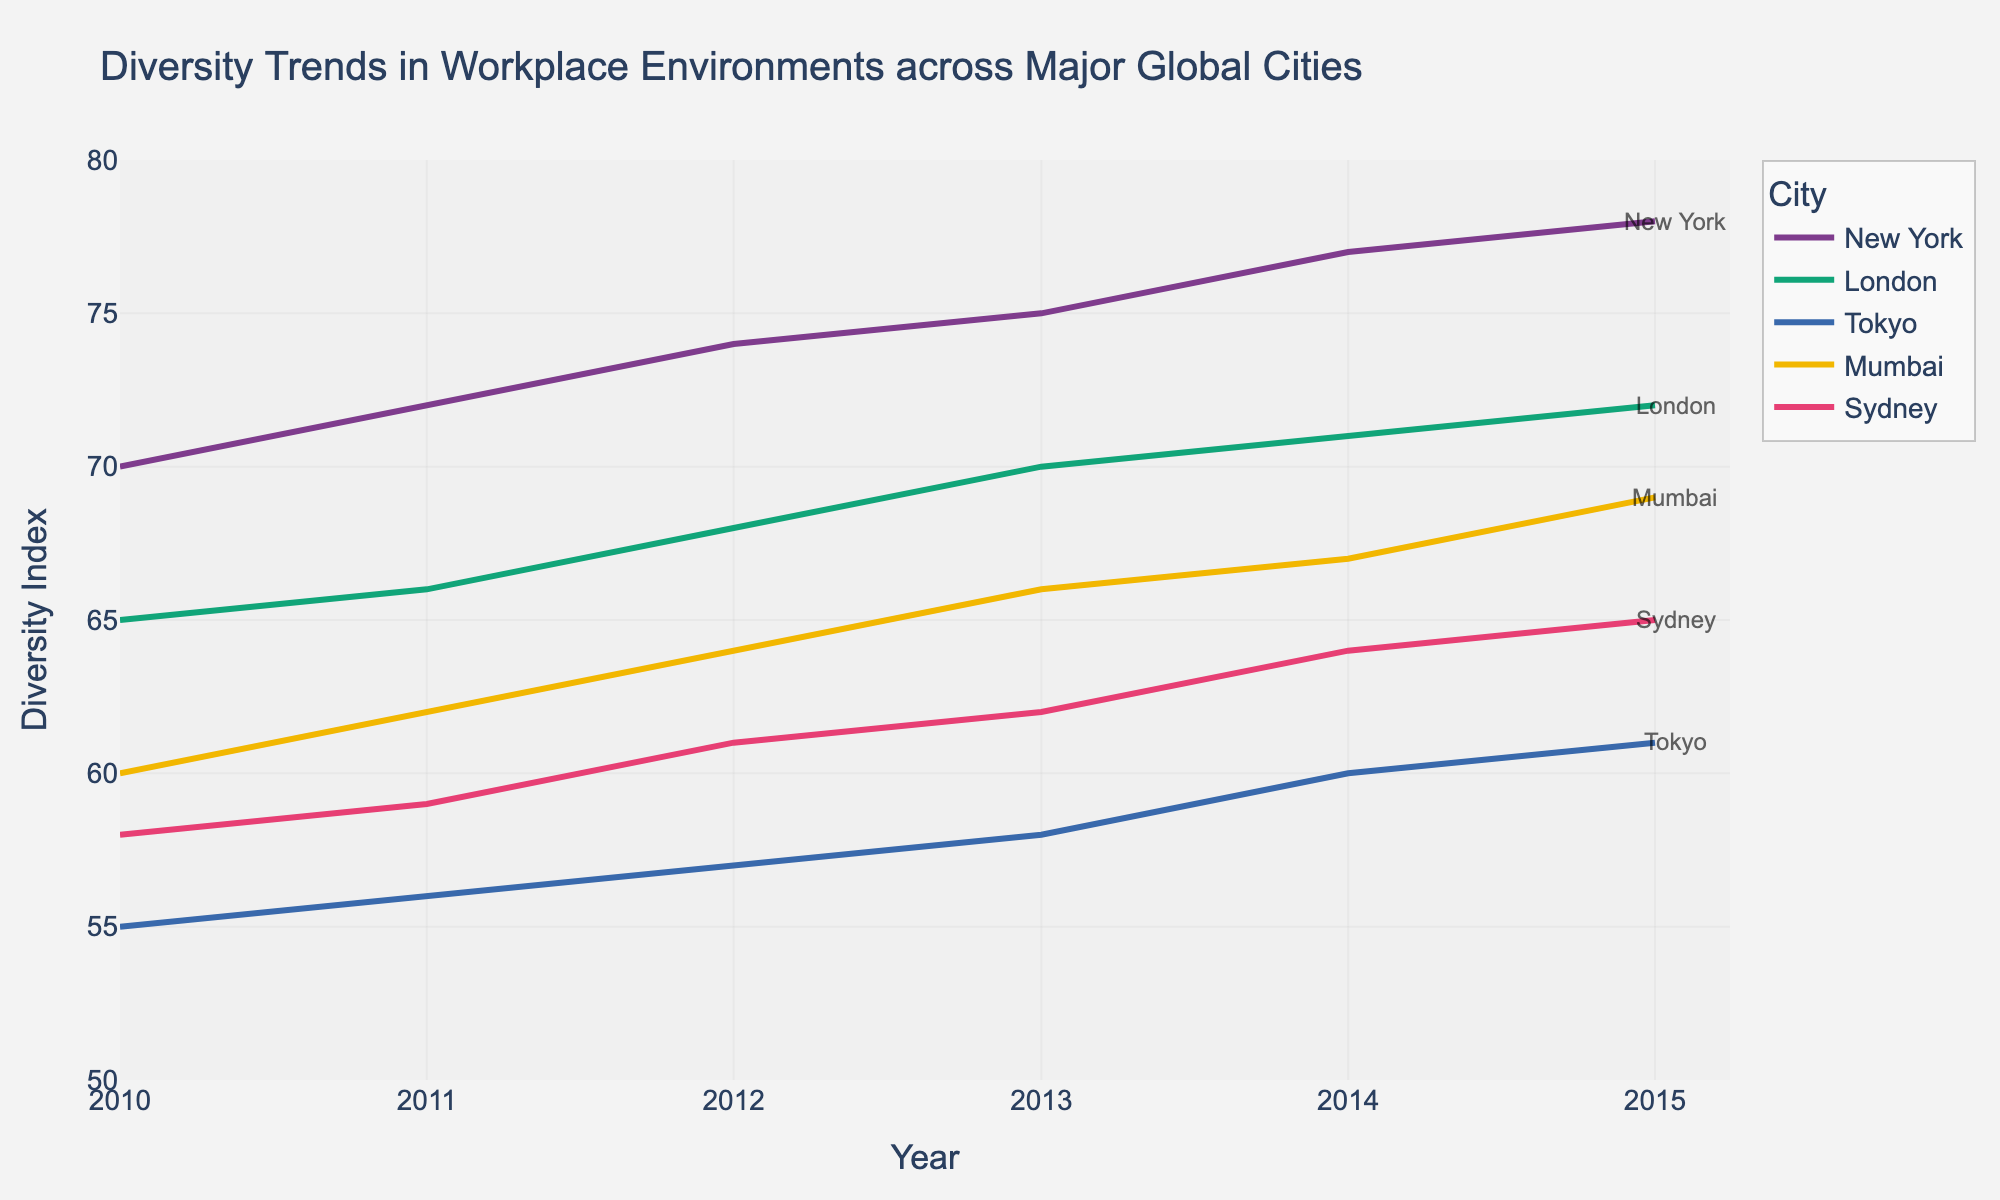what trend is observed in the Diversity Index for New York from 2010 to 2015? The Diversity Index for New York shows a consistent and gradual increase from 70 in 2010 to 78 in 2015. This is observed by looking at the upward slope of the line representing New York on the plot.
Answer: Increasing What city had the lowest Diversity Index in 2010? The Diversity Index for each city in 2010 is plotted, and Tokyo has the lowest index value of 55 in that year.
Answer: Tokyo Which city shows the highest overall growth in Diversity Index from 2010 to 2015? To find the highest growth, calculate the difference in Diversity Index between 2010 and 2015 for each city. New York had a growth of 8 points (78 - 70), London 7 points (72 - 65), Tokyo 6 points (61 - 55), Mumbai 9 points (69 - 60), and Sydney 7 points (65 - 58). Mumbai has the highest overall growth.
Answer: Mumbai What is the average Diversity Index for Sydney over the time period shown? To find the average Diversity Index, sum up the values for each year for Sydney (58, 59, 61, 62, 64, 65) and divide by the number of years. The sum is 369, so the average is 369/6 = 61.5.
Answer: 61.5 In which year did London surpass the Diversity Index of 70? By examining the line representing London, it surpasses the Diversity Index of 70 in the year 2013 when the value reaches 71.
Answer: 2013 How do the Diversity Index trends of Tokyo and Mumbai compare? Both Tokyo and Mumbai show an increasing trend over the years. However, Mumbai starts higher and increases more rapidly, eventually reaching a higher Diversity Index (69 versus Tokyo's 61) in 2015.
Answer: Mumbai increases more rapidly and ends higher Did any city experience a decline in their Diversity Index in any year? By examining each city's trend line, there is no year where any city's Diversity Index decreases from the previous year; hence, there is no decline observed for any city.
Answer: No Which two cities had nearly parallel trends in their Diversity Index? The trends for London and Sydney are nearly parallel, both showing a steady, consistent increase without any sharp fluctuations.
Answer: London and Sydney What can be inferred about global trends in workplace diversity from this plot? All the major global cities depicted (New York, London, Tokyo, Mumbai, Sydney) show an increasing trend in their Diversity Index from 2010 to 2015, indicating a global positive trend towards increasing diversity in workplace environments.
Answer: Increasing global workplace diversity 